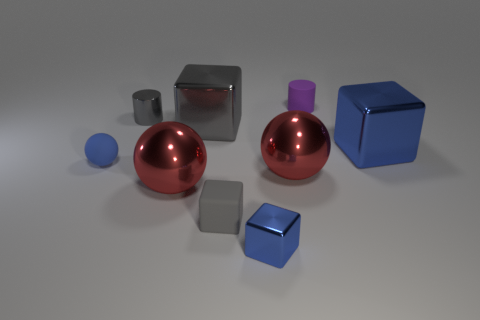Subtract all spheres. How many objects are left? 6 Subtract 2 red balls. How many objects are left? 7 Subtract all large brown objects. Subtract all tiny gray metallic cylinders. How many objects are left? 8 Add 6 purple cylinders. How many purple cylinders are left? 7 Add 4 large red metallic things. How many large red metallic things exist? 6 